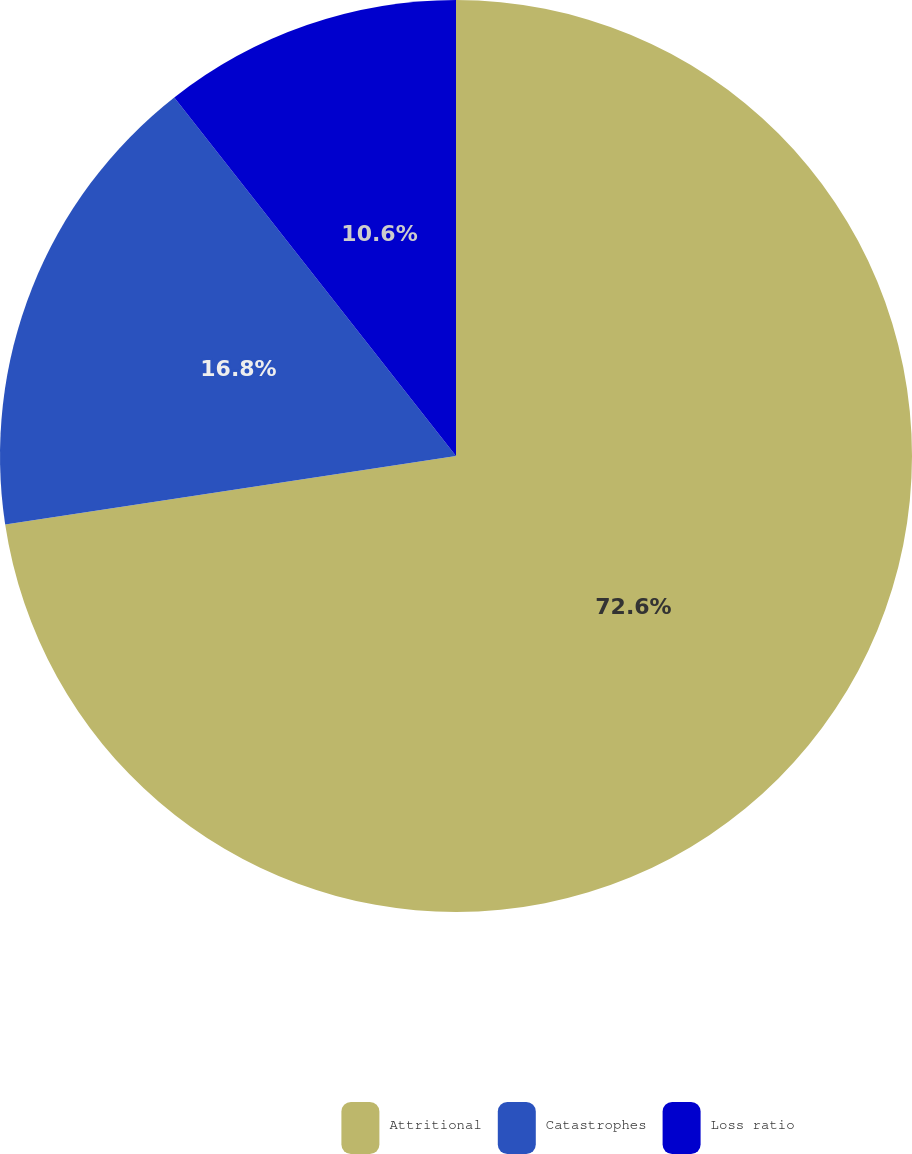Convert chart to OTSL. <chart><loc_0><loc_0><loc_500><loc_500><pie_chart><fcel>Attritional<fcel>Catastrophes<fcel>Loss ratio<nl><fcel>72.6%<fcel>16.8%<fcel>10.6%<nl></chart> 